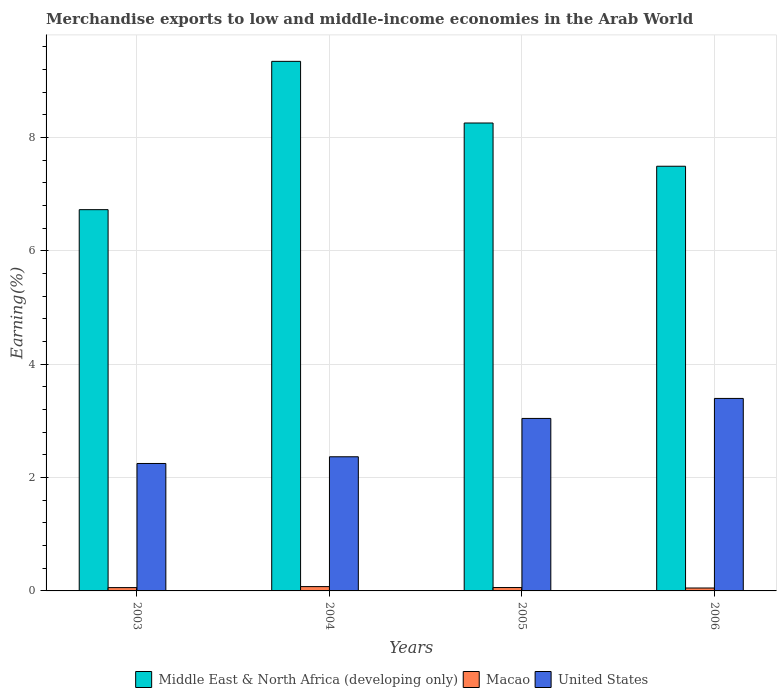How many different coloured bars are there?
Provide a short and direct response. 3. How many groups of bars are there?
Offer a terse response. 4. Are the number of bars on each tick of the X-axis equal?
Offer a terse response. Yes. How many bars are there on the 1st tick from the left?
Keep it short and to the point. 3. In how many cases, is the number of bars for a given year not equal to the number of legend labels?
Provide a short and direct response. 0. What is the percentage of amount earned from merchandise exports in United States in 2004?
Ensure brevity in your answer.  2.37. Across all years, what is the maximum percentage of amount earned from merchandise exports in Macao?
Give a very brief answer. 0.08. Across all years, what is the minimum percentage of amount earned from merchandise exports in Middle East & North Africa (developing only)?
Ensure brevity in your answer.  6.73. What is the total percentage of amount earned from merchandise exports in United States in the graph?
Ensure brevity in your answer.  11.05. What is the difference between the percentage of amount earned from merchandise exports in Macao in 2003 and that in 2005?
Give a very brief answer. -0. What is the difference between the percentage of amount earned from merchandise exports in United States in 2006 and the percentage of amount earned from merchandise exports in Macao in 2004?
Ensure brevity in your answer.  3.32. What is the average percentage of amount earned from merchandise exports in Macao per year?
Ensure brevity in your answer.  0.06. In the year 2006, what is the difference between the percentage of amount earned from merchandise exports in United States and percentage of amount earned from merchandise exports in Middle East & North Africa (developing only)?
Your answer should be compact. -4.1. What is the ratio of the percentage of amount earned from merchandise exports in United States in 2003 to that in 2004?
Offer a very short reply. 0.95. What is the difference between the highest and the second highest percentage of amount earned from merchandise exports in United States?
Your answer should be very brief. 0.35. What is the difference between the highest and the lowest percentage of amount earned from merchandise exports in Macao?
Your answer should be very brief. 0.02. What does the 1st bar from the left in 2004 represents?
Provide a short and direct response. Middle East & North Africa (developing only). What does the 1st bar from the right in 2005 represents?
Provide a succinct answer. United States. Is it the case that in every year, the sum of the percentage of amount earned from merchandise exports in United States and percentage of amount earned from merchandise exports in Macao is greater than the percentage of amount earned from merchandise exports in Middle East & North Africa (developing only)?
Your response must be concise. No. How many years are there in the graph?
Keep it short and to the point. 4. Are the values on the major ticks of Y-axis written in scientific E-notation?
Provide a succinct answer. No. Where does the legend appear in the graph?
Provide a succinct answer. Bottom center. What is the title of the graph?
Give a very brief answer. Merchandise exports to low and middle-income economies in the Arab World. What is the label or title of the X-axis?
Offer a very short reply. Years. What is the label or title of the Y-axis?
Ensure brevity in your answer.  Earning(%). What is the Earning(%) of Middle East & North Africa (developing only) in 2003?
Your response must be concise. 6.73. What is the Earning(%) in Macao in 2003?
Your response must be concise. 0.06. What is the Earning(%) of United States in 2003?
Offer a very short reply. 2.25. What is the Earning(%) in Middle East & North Africa (developing only) in 2004?
Give a very brief answer. 9.34. What is the Earning(%) of Macao in 2004?
Your answer should be compact. 0.08. What is the Earning(%) of United States in 2004?
Your answer should be compact. 2.37. What is the Earning(%) in Middle East & North Africa (developing only) in 2005?
Offer a very short reply. 8.25. What is the Earning(%) of Macao in 2005?
Your answer should be very brief. 0.06. What is the Earning(%) in United States in 2005?
Give a very brief answer. 3.04. What is the Earning(%) in Middle East & North Africa (developing only) in 2006?
Provide a short and direct response. 7.49. What is the Earning(%) in Macao in 2006?
Offer a very short reply. 0.05. What is the Earning(%) in United States in 2006?
Your response must be concise. 3.4. Across all years, what is the maximum Earning(%) of Middle East & North Africa (developing only)?
Make the answer very short. 9.34. Across all years, what is the maximum Earning(%) in Macao?
Give a very brief answer. 0.08. Across all years, what is the maximum Earning(%) in United States?
Give a very brief answer. 3.4. Across all years, what is the minimum Earning(%) in Middle East & North Africa (developing only)?
Provide a short and direct response. 6.73. Across all years, what is the minimum Earning(%) of Macao?
Ensure brevity in your answer.  0.05. Across all years, what is the minimum Earning(%) in United States?
Ensure brevity in your answer.  2.25. What is the total Earning(%) in Middle East & North Africa (developing only) in the graph?
Give a very brief answer. 31.81. What is the total Earning(%) in Macao in the graph?
Offer a terse response. 0.25. What is the total Earning(%) in United States in the graph?
Give a very brief answer. 11.05. What is the difference between the Earning(%) of Middle East & North Africa (developing only) in 2003 and that in 2004?
Your answer should be compact. -2.62. What is the difference between the Earning(%) of Macao in 2003 and that in 2004?
Give a very brief answer. -0.02. What is the difference between the Earning(%) in United States in 2003 and that in 2004?
Provide a short and direct response. -0.12. What is the difference between the Earning(%) in Middle East & North Africa (developing only) in 2003 and that in 2005?
Offer a terse response. -1.53. What is the difference between the Earning(%) in Macao in 2003 and that in 2005?
Your answer should be very brief. -0. What is the difference between the Earning(%) of United States in 2003 and that in 2005?
Keep it short and to the point. -0.79. What is the difference between the Earning(%) of Middle East & North Africa (developing only) in 2003 and that in 2006?
Provide a short and direct response. -0.77. What is the difference between the Earning(%) in Macao in 2003 and that in 2006?
Keep it short and to the point. 0.01. What is the difference between the Earning(%) in United States in 2003 and that in 2006?
Your answer should be very brief. -1.15. What is the difference between the Earning(%) in Middle East & North Africa (developing only) in 2004 and that in 2005?
Your response must be concise. 1.09. What is the difference between the Earning(%) of Macao in 2004 and that in 2005?
Keep it short and to the point. 0.02. What is the difference between the Earning(%) of United States in 2004 and that in 2005?
Make the answer very short. -0.68. What is the difference between the Earning(%) of Middle East & North Africa (developing only) in 2004 and that in 2006?
Your response must be concise. 1.85. What is the difference between the Earning(%) of Macao in 2004 and that in 2006?
Give a very brief answer. 0.03. What is the difference between the Earning(%) of United States in 2004 and that in 2006?
Offer a very short reply. -1.03. What is the difference between the Earning(%) in Middle East & North Africa (developing only) in 2005 and that in 2006?
Ensure brevity in your answer.  0.76. What is the difference between the Earning(%) of Macao in 2005 and that in 2006?
Keep it short and to the point. 0.01. What is the difference between the Earning(%) in United States in 2005 and that in 2006?
Provide a short and direct response. -0.35. What is the difference between the Earning(%) in Middle East & North Africa (developing only) in 2003 and the Earning(%) in Macao in 2004?
Provide a short and direct response. 6.65. What is the difference between the Earning(%) in Middle East & North Africa (developing only) in 2003 and the Earning(%) in United States in 2004?
Your answer should be very brief. 4.36. What is the difference between the Earning(%) of Macao in 2003 and the Earning(%) of United States in 2004?
Ensure brevity in your answer.  -2.31. What is the difference between the Earning(%) in Middle East & North Africa (developing only) in 2003 and the Earning(%) in Macao in 2005?
Your answer should be compact. 6.67. What is the difference between the Earning(%) in Middle East & North Africa (developing only) in 2003 and the Earning(%) in United States in 2005?
Offer a terse response. 3.68. What is the difference between the Earning(%) in Macao in 2003 and the Earning(%) in United States in 2005?
Keep it short and to the point. -2.98. What is the difference between the Earning(%) of Middle East & North Africa (developing only) in 2003 and the Earning(%) of Macao in 2006?
Keep it short and to the point. 6.67. What is the difference between the Earning(%) of Middle East & North Africa (developing only) in 2003 and the Earning(%) of United States in 2006?
Give a very brief answer. 3.33. What is the difference between the Earning(%) of Macao in 2003 and the Earning(%) of United States in 2006?
Offer a terse response. -3.34. What is the difference between the Earning(%) of Middle East & North Africa (developing only) in 2004 and the Earning(%) of Macao in 2005?
Give a very brief answer. 9.28. What is the difference between the Earning(%) in Middle East & North Africa (developing only) in 2004 and the Earning(%) in United States in 2005?
Provide a succinct answer. 6.3. What is the difference between the Earning(%) in Macao in 2004 and the Earning(%) in United States in 2005?
Offer a terse response. -2.97. What is the difference between the Earning(%) of Middle East & North Africa (developing only) in 2004 and the Earning(%) of Macao in 2006?
Your answer should be very brief. 9.29. What is the difference between the Earning(%) of Middle East & North Africa (developing only) in 2004 and the Earning(%) of United States in 2006?
Offer a very short reply. 5.95. What is the difference between the Earning(%) of Macao in 2004 and the Earning(%) of United States in 2006?
Offer a terse response. -3.32. What is the difference between the Earning(%) of Middle East & North Africa (developing only) in 2005 and the Earning(%) of Macao in 2006?
Your response must be concise. 8.2. What is the difference between the Earning(%) of Middle East & North Africa (developing only) in 2005 and the Earning(%) of United States in 2006?
Your answer should be very brief. 4.86. What is the difference between the Earning(%) of Macao in 2005 and the Earning(%) of United States in 2006?
Make the answer very short. -3.34. What is the average Earning(%) of Middle East & North Africa (developing only) per year?
Keep it short and to the point. 7.95. What is the average Earning(%) of Macao per year?
Provide a succinct answer. 0.06. What is the average Earning(%) of United States per year?
Your answer should be very brief. 2.76. In the year 2003, what is the difference between the Earning(%) of Middle East & North Africa (developing only) and Earning(%) of Macao?
Your answer should be compact. 6.67. In the year 2003, what is the difference between the Earning(%) of Middle East & North Africa (developing only) and Earning(%) of United States?
Your answer should be compact. 4.48. In the year 2003, what is the difference between the Earning(%) of Macao and Earning(%) of United States?
Provide a short and direct response. -2.19. In the year 2004, what is the difference between the Earning(%) of Middle East & North Africa (developing only) and Earning(%) of Macao?
Give a very brief answer. 9.27. In the year 2004, what is the difference between the Earning(%) in Middle East & North Africa (developing only) and Earning(%) in United States?
Ensure brevity in your answer.  6.98. In the year 2004, what is the difference between the Earning(%) of Macao and Earning(%) of United States?
Make the answer very short. -2.29. In the year 2005, what is the difference between the Earning(%) of Middle East & North Africa (developing only) and Earning(%) of Macao?
Your response must be concise. 8.19. In the year 2005, what is the difference between the Earning(%) of Middle East & North Africa (developing only) and Earning(%) of United States?
Provide a succinct answer. 5.21. In the year 2005, what is the difference between the Earning(%) in Macao and Earning(%) in United States?
Offer a terse response. -2.98. In the year 2006, what is the difference between the Earning(%) in Middle East & North Africa (developing only) and Earning(%) in Macao?
Offer a very short reply. 7.44. In the year 2006, what is the difference between the Earning(%) of Middle East & North Africa (developing only) and Earning(%) of United States?
Make the answer very short. 4.1. In the year 2006, what is the difference between the Earning(%) in Macao and Earning(%) in United States?
Your answer should be compact. -3.34. What is the ratio of the Earning(%) of Middle East & North Africa (developing only) in 2003 to that in 2004?
Ensure brevity in your answer.  0.72. What is the ratio of the Earning(%) in Macao in 2003 to that in 2004?
Your answer should be compact. 0.77. What is the ratio of the Earning(%) of Middle East & North Africa (developing only) in 2003 to that in 2005?
Your answer should be very brief. 0.81. What is the ratio of the Earning(%) in Macao in 2003 to that in 2005?
Your answer should be very brief. 0.98. What is the ratio of the Earning(%) in United States in 2003 to that in 2005?
Your response must be concise. 0.74. What is the ratio of the Earning(%) of Middle East & North Africa (developing only) in 2003 to that in 2006?
Give a very brief answer. 0.9. What is the ratio of the Earning(%) in Macao in 2003 to that in 2006?
Ensure brevity in your answer.  1.14. What is the ratio of the Earning(%) in United States in 2003 to that in 2006?
Offer a very short reply. 0.66. What is the ratio of the Earning(%) of Middle East & North Africa (developing only) in 2004 to that in 2005?
Make the answer very short. 1.13. What is the ratio of the Earning(%) of Macao in 2004 to that in 2005?
Keep it short and to the point. 1.28. What is the ratio of the Earning(%) of United States in 2004 to that in 2005?
Your response must be concise. 0.78. What is the ratio of the Earning(%) in Middle East & North Africa (developing only) in 2004 to that in 2006?
Offer a terse response. 1.25. What is the ratio of the Earning(%) of Macao in 2004 to that in 2006?
Your answer should be compact. 1.49. What is the ratio of the Earning(%) in United States in 2004 to that in 2006?
Your answer should be very brief. 0.7. What is the ratio of the Earning(%) in Middle East & North Africa (developing only) in 2005 to that in 2006?
Make the answer very short. 1.1. What is the ratio of the Earning(%) of Macao in 2005 to that in 2006?
Your response must be concise. 1.17. What is the ratio of the Earning(%) of United States in 2005 to that in 2006?
Your answer should be compact. 0.9. What is the difference between the highest and the second highest Earning(%) of Middle East & North Africa (developing only)?
Offer a terse response. 1.09. What is the difference between the highest and the second highest Earning(%) in Macao?
Your response must be concise. 0.02. What is the difference between the highest and the second highest Earning(%) of United States?
Give a very brief answer. 0.35. What is the difference between the highest and the lowest Earning(%) of Middle East & North Africa (developing only)?
Provide a succinct answer. 2.62. What is the difference between the highest and the lowest Earning(%) of Macao?
Keep it short and to the point. 0.03. What is the difference between the highest and the lowest Earning(%) of United States?
Provide a short and direct response. 1.15. 